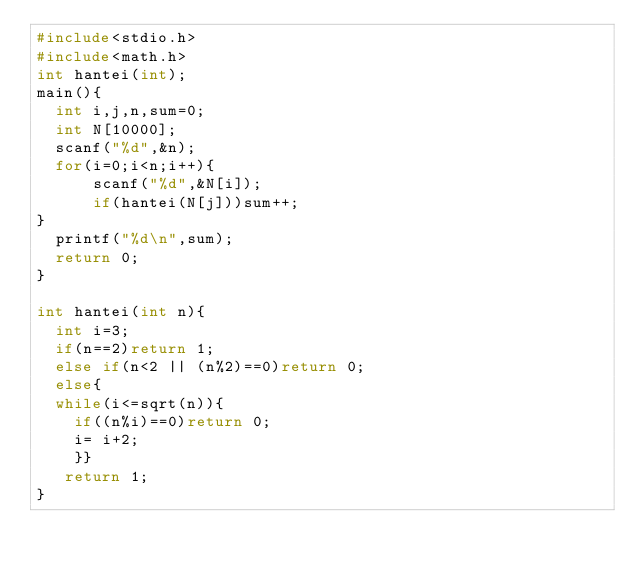<code> <loc_0><loc_0><loc_500><loc_500><_C_>#include<stdio.h>
#include<math.h>
int hantei(int);
main(){
  int i,j,n,sum=0;
  int N[10000];
  scanf("%d",&n);
  for(i=0;i<n;i++){ 
      scanf("%d",&N[i]);
      if(hantei(N[j]))sum++; 
} 
  printf("%d\n",sum);
  return 0;
}

int hantei(int n){
  int i=3;
  if(n==2)return 1;
  else if(n<2 || (n%2)==0)return 0;
  else{
  while(i<=sqrt(n)){
    if((n%i)==0)return 0;
    i= i+2;
    }}
   return 1;
}</code> 